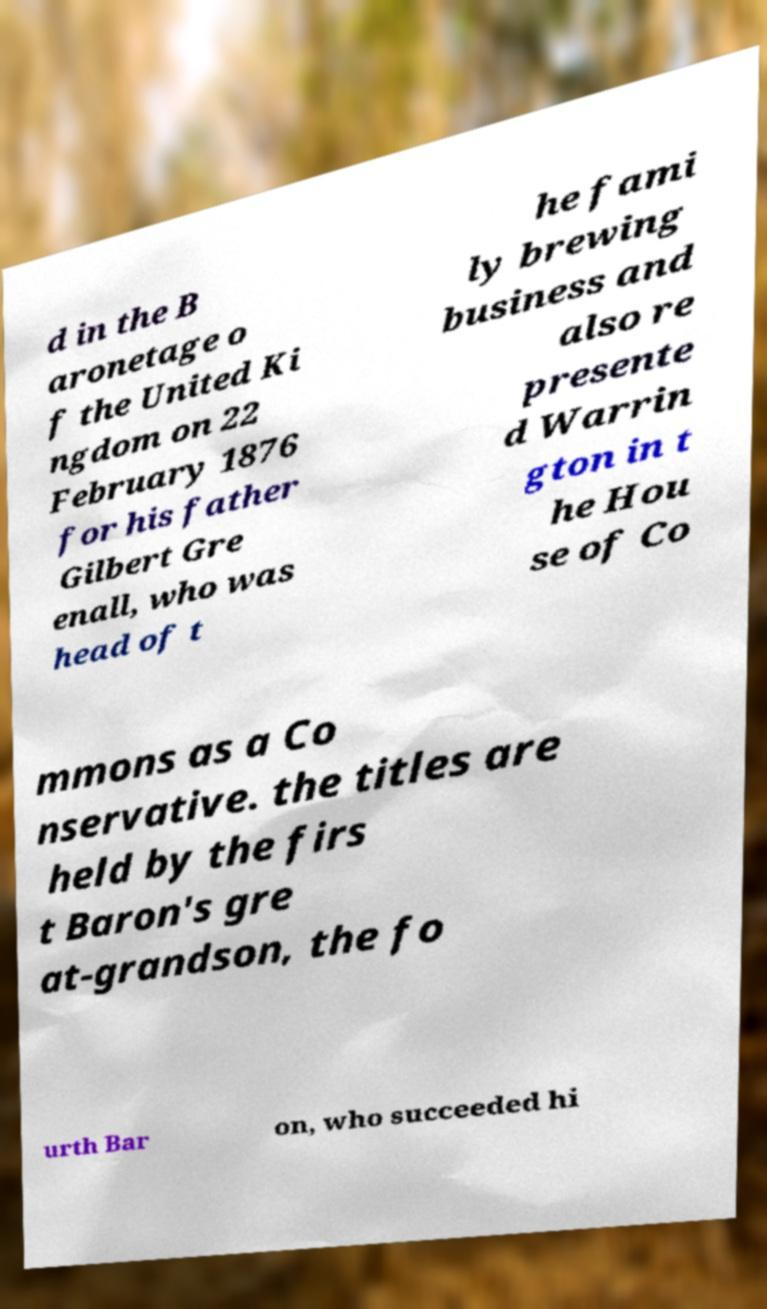For documentation purposes, I need the text within this image transcribed. Could you provide that? d in the B aronetage o f the United Ki ngdom on 22 February 1876 for his father Gilbert Gre enall, who was head of t he fami ly brewing business and also re presente d Warrin gton in t he Hou se of Co mmons as a Co nservative. the titles are held by the firs t Baron's gre at-grandson, the fo urth Bar on, who succeeded hi 